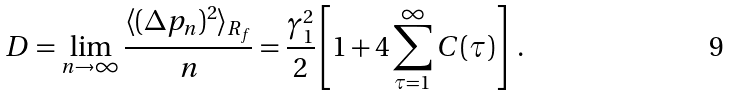Convert formula to latex. <formula><loc_0><loc_0><loc_500><loc_500>D = \lim _ { n \rightarrow \infty } \frac { \langle ( \Delta p _ { n } ) ^ { 2 } \rangle _ { R _ { f } } } { n } = \frac { \gamma _ { 1 } ^ { 2 } } { 2 } \left [ 1 + 4 \sum _ { \tau = 1 } ^ { \infty } C ( \tau ) \right ] \ .</formula> 